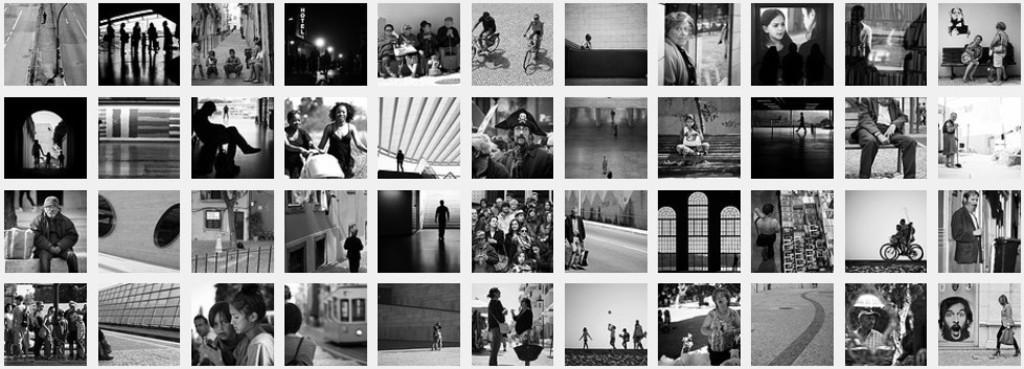Describe this image in one or two sentences. This is a collage of different images in which we can see a group of people. 